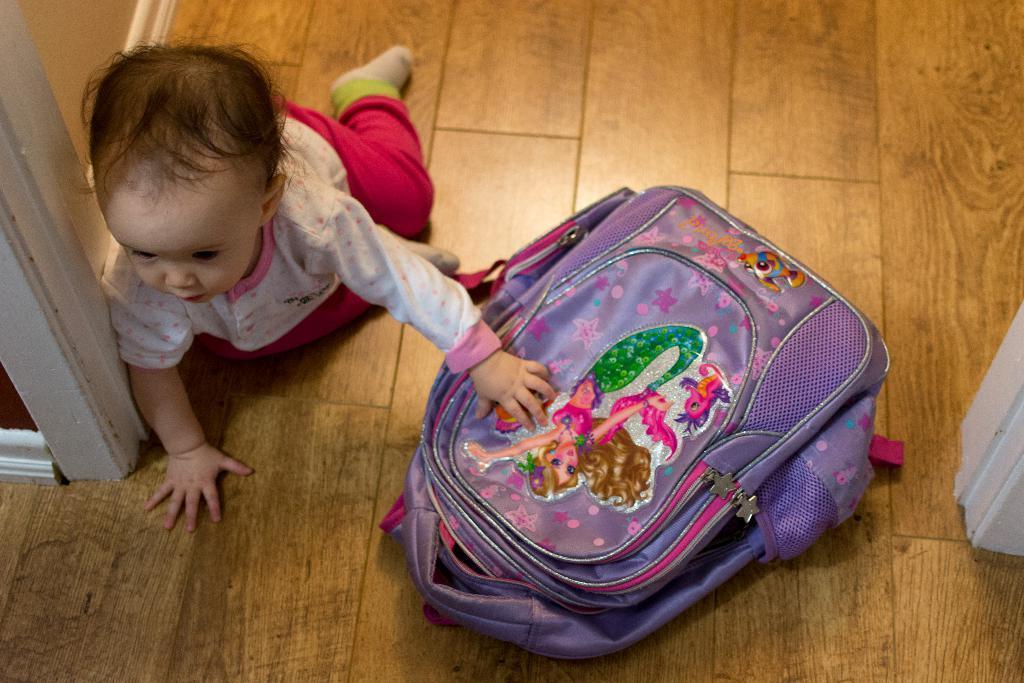Describe this image in one or two sentences. In this image we can see a kid. At the bottom there is a bag placed on the floor. 